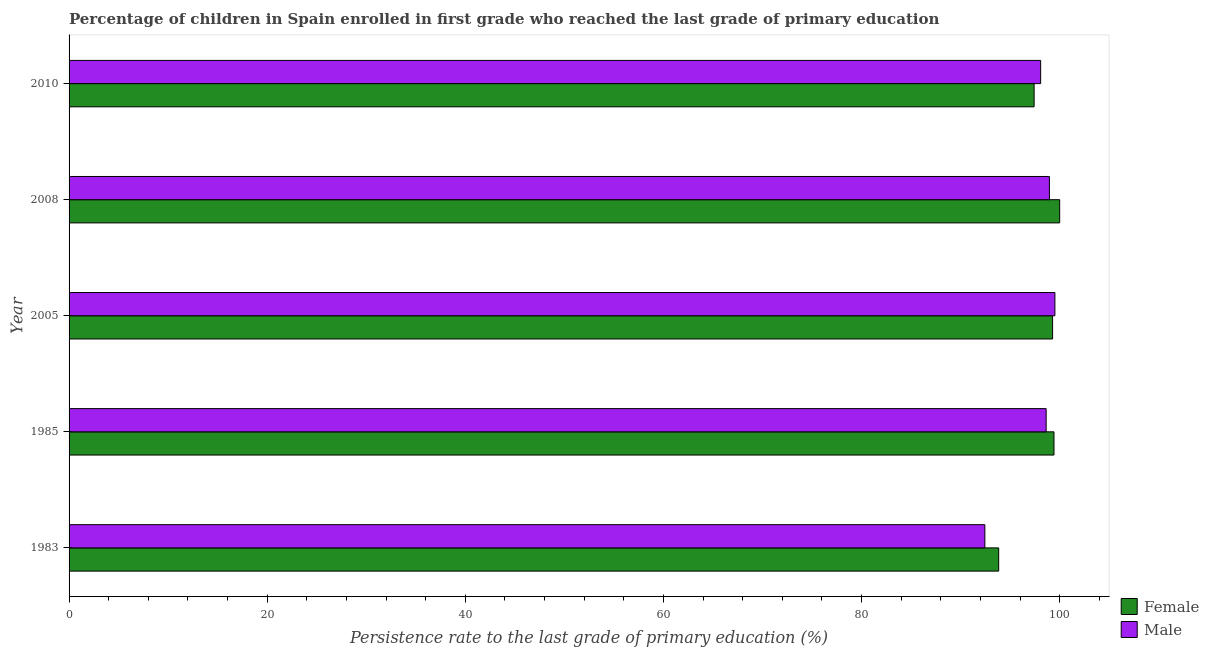Are the number of bars per tick equal to the number of legend labels?
Provide a succinct answer. Yes. Are the number of bars on each tick of the Y-axis equal?
Your answer should be compact. Yes. How many bars are there on the 5th tick from the top?
Your answer should be very brief. 2. How many bars are there on the 4th tick from the bottom?
Give a very brief answer. 2. What is the persistence rate of female students in 2005?
Provide a succinct answer. 99.28. Across all years, what is the maximum persistence rate of male students?
Offer a terse response. 99.52. Across all years, what is the minimum persistence rate of female students?
Keep it short and to the point. 93.84. What is the total persistence rate of male students in the graph?
Give a very brief answer. 487.64. What is the difference between the persistence rate of female students in 1983 and that in 2008?
Ensure brevity in your answer.  -6.16. What is the difference between the persistence rate of female students in 1985 and the persistence rate of male students in 2005?
Offer a very short reply. -0.09. What is the average persistence rate of female students per year?
Make the answer very short. 97.99. In the year 1985, what is the difference between the persistence rate of female students and persistence rate of male students?
Give a very brief answer. 0.79. What is the ratio of the persistence rate of female students in 1985 to that in 2008?
Your answer should be very brief. 0.99. What is the difference between the highest and the second highest persistence rate of male students?
Offer a very short reply. 0.56. What is the difference between the highest and the lowest persistence rate of female students?
Make the answer very short. 6.16. In how many years, is the persistence rate of female students greater than the average persistence rate of female students taken over all years?
Keep it short and to the point. 3. Is the sum of the persistence rate of female students in 1985 and 2005 greater than the maximum persistence rate of male students across all years?
Give a very brief answer. Yes. What does the 2nd bar from the top in 2005 represents?
Your answer should be compact. Female. What is the difference between two consecutive major ticks on the X-axis?
Give a very brief answer. 20. Are the values on the major ticks of X-axis written in scientific E-notation?
Your response must be concise. No. Does the graph contain any zero values?
Keep it short and to the point. No. How many legend labels are there?
Make the answer very short. 2. What is the title of the graph?
Make the answer very short. Percentage of children in Spain enrolled in first grade who reached the last grade of primary education. Does "Female labourers" appear as one of the legend labels in the graph?
Give a very brief answer. No. What is the label or title of the X-axis?
Your answer should be compact. Persistence rate to the last grade of primary education (%). What is the label or title of the Y-axis?
Your answer should be compact. Year. What is the Persistence rate to the last grade of primary education (%) of Female in 1983?
Provide a succinct answer. 93.84. What is the Persistence rate to the last grade of primary education (%) of Male in 1983?
Offer a very short reply. 92.45. What is the Persistence rate to the last grade of primary education (%) of Female in 1985?
Ensure brevity in your answer.  99.42. What is the Persistence rate to the last grade of primary education (%) of Male in 1985?
Keep it short and to the point. 98.63. What is the Persistence rate to the last grade of primary education (%) of Female in 2005?
Make the answer very short. 99.28. What is the Persistence rate to the last grade of primary education (%) in Male in 2005?
Offer a terse response. 99.52. What is the Persistence rate to the last grade of primary education (%) in Female in 2008?
Make the answer very short. 100. What is the Persistence rate to the last grade of primary education (%) of Male in 2008?
Your response must be concise. 98.96. What is the Persistence rate to the last grade of primary education (%) of Female in 2010?
Offer a very short reply. 97.42. What is the Persistence rate to the last grade of primary education (%) in Male in 2010?
Provide a succinct answer. 98.08. Across all years, what is the maximum Persistence rate to the last grade of primary education (%) in Female?
Your answer should be compact. 100. Across all years, what is the maximum Persistence rate to the last grade of primary education (%) of Male?
Give a very brief answer. 99.52. Across all years, what is the minimum Persistence rate to the last grade of primary education (%) in Female?
Give a very brief answer. 93.84. Across all years, what is the minimum Persistence rate to the last grade of primary education (%) of Male?
Offer a very short reply. 92.45. What is the total Persistence rate to the last grade of primary education (%) of Female in the graph?
Provide a short and direct response. 489.97. What is the total Persistence rate to the last grade of primary education (%) in Male in the graph?
Offer a very short reply. 487.64. What is the difference between the Persistence rate to the last grade of primary education (%) in Female in 1983 and that in 1985?
Your response must be concise. -5.58. What is the difference between the Persistence rate to the last grade of primary education (%) of Male in 1983 and that in 1985?
Make the answer very short. -6.19. What is the difference between the Persistence rate to the last grade of primary education (%) of Female in 1983 and that in 2005?
Your response must be concise. -5.44. What is the difference between the Persistence rate to the last grade of primary education (%) in Male in 1983 and that in 2005?
Provide a succinct answer. -7.07. What is the difference between the Persistence rate to the last grade of primary education (%) in Female in 1983 and that in 2008?
Offer a very short reply. -6.16. What is the difference between the Persistence rate to the last grade of primary education (%) in Male in 1983 and that in 2008?
Make the answer very short. -6.52. What is the difference between the Persistence rate to the last grade of primary education (%) in Female in 1983 and that in 2010?
Your answer should be very brief. -3.58. What is the difference between the Persistence rate to the last grade of primary education (%) in Male in 1983 and that in 2010?
Give a very brief answer. -5.63. What is the difference between the Persistence rate to the last grade of primary education (%) of Female in 1985 and that in 2005?
Make the answer very short. 0.14. What is the difference between the Persistence rate to the last grade of primary education (%) of Male in 1985 and that in 2005?
Ensure brevity in your answer.  -0.88. What is the difference between the Persistence rate to the last grade of primary education (%) in Female in 1985 and that in 2008?
Offer a terse response. -0.57. What is the difference between the Persistence rate to the last grade of primary education (%) of Male in 1985 and that in 2008?
Your response must be concise. -0.33. What is the difference between the Persistence rate to the last grade of primary education (%) of Female in 1985 and that in 2010?
Your response must be concise. 2.01. What is the difference between the Persistence rate to the last grade of primary education (%) in Male in 1985 and that in 2010?
Keep it short and to the point. 0.56. What is the difference between the Persistence rate to the last grade of primary education (%) of Female in 2005 and that in 2008?
Make the answer very short. -0.71. What is the difference between the Persistence rate to the last grade of primary education (%) in Male in 2005 and that in 2008?
Provide a short and direct response. 0.55. What is the difference between the Persistence rate to the last grade of primary education (%) of Female in 2005 and that in 2010?
Keep it short and to the point. 1.87. What is the difference between the Persistence rate to the last grade of primary education (%) in Male in 2005 and that in 2010?
Keep it short and to the point. 1.44. What is the difference between the Persistence rate to the last grade of primary education (%) of Female in 2008 and that in 2010?
Ensure brevity in your answer.  2.58. What is the difference between the Persistence rate to the last grade of primary education (%) in Male in 2008 and that in 2010?
Your answer should be compact. 0.88. What is the difference between the Persistence rate to the last grade of primary education (%) in Female in 1983 and the Persistence rate to the last grade of primary education (%) in Male in 1985?
Ensure brevity in your answer.  -4.79. What is the difference between the Persistence rate to the last grade of primary education (%) in Female in 1983 and the Persistence rate to the last grade of primary education (%) in Male in 2005?
Provide a short and direct response. -5.68. What is the difference between the Persistence rate to the last grade of primary education (%) of Female in 1983 and the Persistence rate to the last grade of primary education (%) of Male in 2008?
Keep it short and to the point. -5.12. What is the difference between the Persistence rate to the last grade of primary education (%) in Female in 1983 and the Persistence rate to the last grade of primary education (%) in Male in 2010?
Make the answer very short. -4.24. What is the difference between the Persistence rate to the last grade of primary education (%) in Female in 1985 and the Persistence rate to the last grade of primary education (%) in Male in 2005?
Your answer should be very brief. -0.09. What is the difference between the Persistence rate to the last grade of primary education (%) in Female in 1985 and the Persistence rate to the last grade of primary education (%) in Male in 2008?
Keep it short and to the point. 0.46. What is the difference between the Persistence rate to the last grade of primary education (%) of Female in 1985 and the Persistence rate to the last grade of primary education (%) of Male in 2010?
Your answer should be very brief. 1.35. What is the difference between the Persistence rate to the last grade of primary education (%) of Female in 2005 and the Persistence rate to the last grade of primary education (%) of Male in 2008?
Your answer should be compact. 0.32. What is the difference between the Persistence rate to the last grade of primary education (%) in Female in 2005 and the Persistence rate to the last grade of primary education (%) in Male in 2010?
Provide a succinct answer. 1.21. What is the difference between the Persistence rate to the last grade of primary education (%) in Female in 2008 and the Persistence rate to the last grade of primary education (%) in Male in 2010?
Keep it short and to the point. 1.92. What is the average Persistence rate to the last grade of primary education (%) in Female per year?
Your answer should be very brief. 97.99. What is the average Persistence rate to the last grade of primary education (%) in Male per year?
Ensure brevity in your answer.  97.53. In the year 1983, what is the difference between the Persistence rate to the last grade of primary education (%) in Female and Persistence rate to the last grade of primary education (%) in Male?
Provide a succinct answer. 1.4. In the year 1985, what is the difference between the Persistence rate to the last grade of primary education (%) in Female and Persistence rate to the last grade of primary education (%) in Male?
Provide a short and direct response. 0.79. In the year 2005, what is the difference between the Persistence rate to the last grade of primary education (%) of Female and Persistence rate to the last grade of primary education (%) of Male?
Ensure brevity in your answer.  -0.23. In the year 2008, what is the difference between the Persistence rate to the last grade of primary education (%) in Female and Persistence rate to the last grade of primary education (%) in Male?
Give a very brief answer. 1.04. In the year 2010, what is the difference between the Persistence rate to the last grade of primary education (%) of Female and Persistence rate to the last grade of primary education (%) of Male?
Provide a short and direct response. -0.66. What is the ratio of the Persistence rate to the last grade of primary education (%) of Female in 1983 to that in 1985?
Keep it short and to the point. 0.94. What is the ratio of the Persistence rate to the last grade of primary education (%) in Male in 1983 to that in 1985?
Offer a very short reply. 0.94. What is the ratio of the Persistence rate to the last grade of primary education (%) of Female in 1983 to that in 2005?
Your answer should be compact. 0.95. What is the ratio of the Persistence rate to the last grade of primary education (%) of Male in 1983 to that in 2005?
Your answer should be compact. 0.93. What is the ratio of the Persistence rate to the last grade of primary education (%) in Female in 1983 to that in 2008?
Offer a very short reply. 0.94. What is the ratio of the Persistence rate to the last grade of primary education (%) of Male in 1983 to that in 2008?
Your answer should be very brief. 0.93. What is the ratio of the Persistence rate to the last grade of primary education (%) in Female in 1983 to that in 2010?
Give a very brief answer. 0.96. What is the ratio of the Persistence rate to the last grade of primary education (%) in Male in 1983 to that in 2010?
Your answer should be compact. 0.94. What is the ratio of the Persistence rate to the last grade of primary education (%) in Female in 1985 to that in 2005?
Keep it short and to the point. 1. What is the ratio of the Persistence rate to the last grade of primary education (%) in Female in 1985 to that in 2008?
Provide a short and direct response. 0.99. What is the ratio of the Persistence rate to the last grade of primary education (%) in Male in 1985 to that in 2008?
Ensure brevity in your answer.  1. What is the ratio of the Persistence rate to the last grade of primary education (%) of Female in 1985 to that in 2010?
Give a very brief answer. 1.02. What is the ratio of the Persistence rate to the last grade of primary education (%) of Male in 1985 to that in 2010?
Offer a very short reply. 1.01. What is the ratio of the Persistence rate to the last grade of primary education (%) in Male in 2005 to that in 2008?
Offer a terse response. 1.01. What is the ratio of the Persistence rate to the last grade of primary education (%) of Female in 2005 to that in 2010?
Your answer should be compact. 1.02. What is the ratio of the Persistence rate to the last grade of primary education (%) in Male in 2005 to that in 2010?
Ensure brevity in your answer.  1.01. What is the ratio of the Persistence rate to the last grade of primary education (%) of Female in 2008 to that in 2010?
Provide a succinct answer. 1.03. What is the ratio of the Persistence rate to the last grade of primary education (%) of Male in 2008 to that in 2010?
Offer a very short reply. 1.01. What is the difference between the highest and the second highest Persistence rate to the last grade of primary education (%) of Female?
Provide a succinct answer. 0.57. What is the difference between the highest and the second highest Persistence rate to the last grade of primary education (%) of Male?
Give a very brief answer. 0.55. What is the difference between the highest and the lowest Persistence rate to the last grade of primary education (%) in Female?
Keep it short and to the point. 6.16. What is the difference between the highest and the lowest Persistence rate to the last grade of primary education (%) of Male?
Keep it short and to the point. 7.07. 